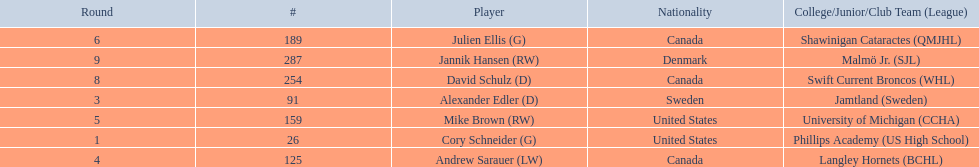Who are all the players? Cory Schneider (G), Alexander Edler (D), Andrew Sarauer (LW), Mike Brown (RW), Julien Ellis (G), David Schulz (D), Jannik Hansen (RW). What is the nationality of each player? United States, Sweden, Canada, United States, Canada, Canada, Denmark. Where did they attend school? Phillips Academy (US High School), Jamtland (Sweden), Langley Hornets (BCHL), University of Michigan (CCHA), Shawinigan Cataractes (QMJHL), Swift Current Broncos (WHL), Malmö Jr. (SJL). Which player attended langley hornets? Andrew Sarauer (LW). 